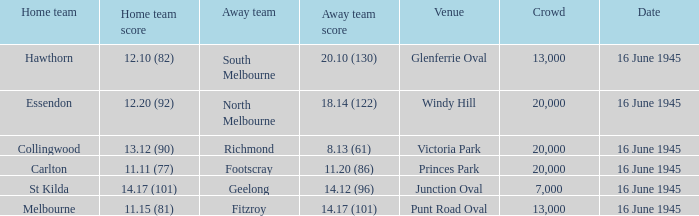What was the Away team score for Footscray? 11.20 (86). 